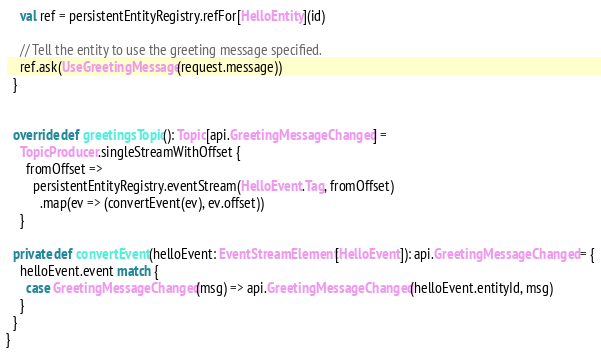Convert code to text. <code><loc_0><loc_0><loc_500><loc_500><_Scala_>    val ref = persistentEntityRegistry.refFor[HelloEntity](id)

    // Tell the entity to use the greeting message specified.
    ref.ask(UseGreetingMessage(request.message))
  }


  override def greetingsTopic(): Topic[api.GreetingMessageChanged] =
    TopicProducer.singleStreamWithOffset {
      fromOffset =>
        persistentEntityRegistry.eventStream(HelloEvent.Tag, fromOffset)
          .map(ev => (convertEvent(ev), ev.offset))
    }

  private def convertEvent(helloEvent: EventStreamElement[HelloEvent]): api.GreetingMessageChanged = {
    helloEvent.event match {
      case GreetingMessageChanged(msg) => api.GreetingMessageChanged(helloEvent.entityId, msg)
    }
  }
}
</code> 